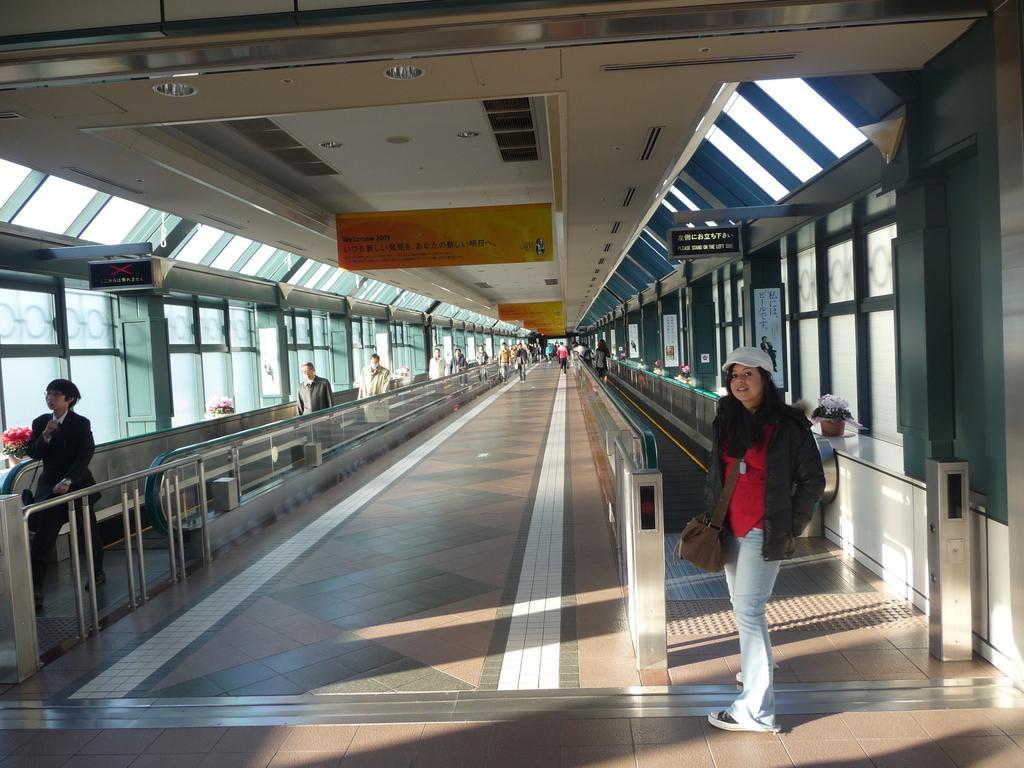Describe this image in one or two sentences. In front of the image there is a woman standing, behind the woman there is an escalator. On the left side of the image there are a few people on the escalator. In the background of the image there are a few people walking. At the top of the image there are sign boards and lamps on the roof. Besides the escalator there are glass windows, on the window platform, there are flower pots. 